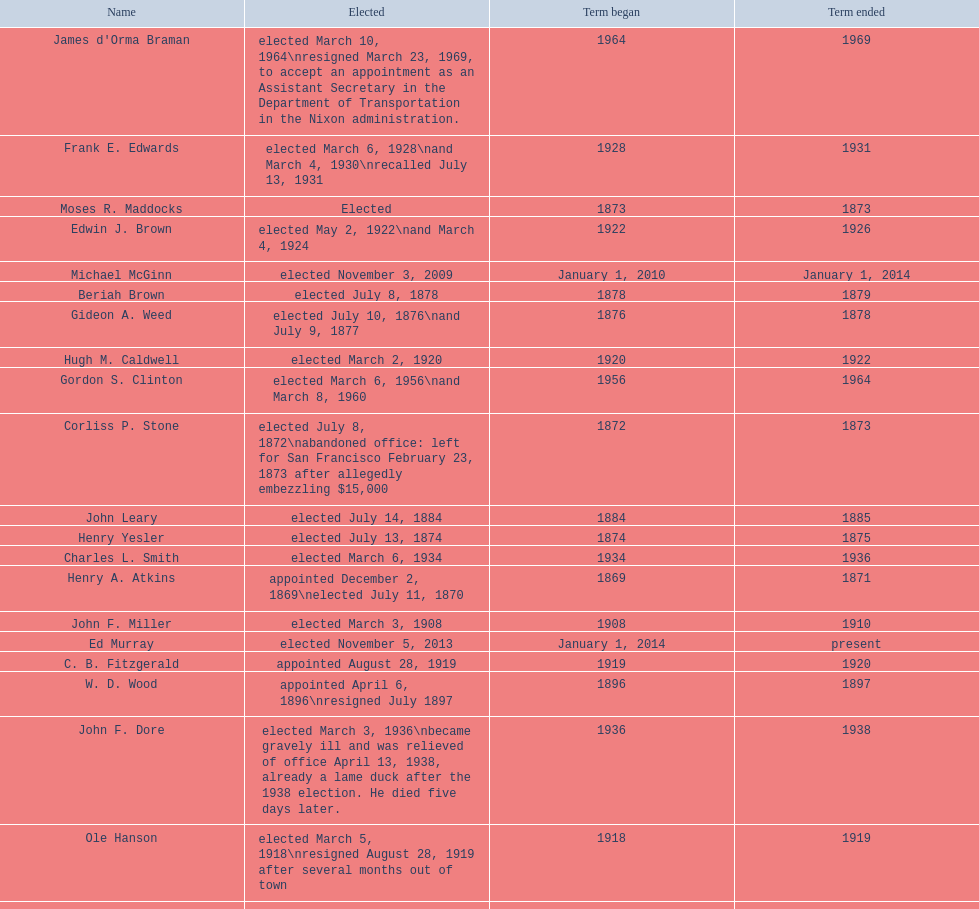Who began their term in 1890? Harry White. Can you give me this table as a dict? {'header': ['Name', 'Elected', 'Term began', 'Term ended'], 'rows': [["James d'Orma Braman", 'elected March 10, 1964\\nresigned March 23, 1969, to accept an appointment as an Assistant Secretary in the Department of Transportation in the Nixon administration.', '1964', '1969'], ['Frank E. Edwards', 'elected March 6, 1928\\nand March 4, 1930\\nrecalled July 13, 1931', '1928', '1931'], ['Moses R. Maddocks', 'Elected', '1873', '1873'], ['Edwin J. Brown', 'elected May 2, 1922\\nand March 4, 1924', '1922', '1926'], ['Michael McGinn', 'elected November 3, 2009', 'January 1, 2010', 'January 1, 2014'], ['Beriah Brown', 'elected July 8, 1878', '1878', '1879'], ['Gideon A. Weed', 'elected July 10, 1876\\nand July 9, 1877', '1876', '1878'], ['Hugh M. Caldwell', 'elected March 2, 1920', '1920', '1922'], ['Gordon S. Clinton', 'elected March 6, 1956\\nand March 8, 1960', '1956', '1964'], ['Corliss P. Stone', 'elected July 8, 1872\\nabandoned office: left for San Francisco February 23, 1873 after allegedly embezzling $15,000', '1872', '1873'], ['John Leary', 'elected July 14, 1884', '1884', '1885'], ['Henry Yesler', 'elected July 13, 1874', '1874', '1875'], ['Charles L. Smith', 'elected March 6, 1934', '1934', '1936'], ['Henry A. Atkins', 'appointed December 2, 1869\\nelected July 11, 1870', '1869', '1871'], ['John F. Miller', 'elected March 3, 1908', '1908', '1910'], ['Ed Murray', 'elected November 5, 2013', 'January 1, 2014', 'present'], ['C. B. Fitzgerald', 'appointed August 28, 1919', '1919', '1920'], ['W. D. Wood', 'appointed April 6, 1896\\nresigned July 1897', '1896', '1897'], ['John F. Dore', 'elected March 3, 1936\\nbecame gravely ill and was relieved of office April 13, 1938, already a lame duck after the 1938 election. He died five days later.', '1936', '1938'], ['Ole Hanson', 'elected March 5, 1918\\nresigned August 28, 1919 after several months out of town', '1918', '1919'], ['John T. Jordan', 'appointed', '1873', '1873'], ['Robert H. Harlin', 'appointed July 14, 1931', '1931', '1932'], ['Leonard Purley Smith', 'elected July 12, 1880\\nand July 11, 1881', '1880', '1882'], ['George W. Dilling', 'appointed February 10, 1911[citation needed]', '1912', ''], ['John F. Dore', 'elected March 8, 1932', '1932', '1934'], ['Byron Phelps', 'elected March 12, 1894', '1894', '1896'], ['Hiram C. Gill', 'elected March 3, 1914', '1914', '1918'], ['John T. Jordan', 'elected July 10, 1871', '1871', '1872'], ['Dr. Thomas T. Minor', 'elected July 11, 1887', '1887', '1888'], ['Henry Yesler', 'elected July 13, 1885', '1885', '1886'], ['Paul Schell', 'elected November 4, 1997', 'January 1, 1998', 'January 1, 2002'], ['Orange Jacobs', 'elected July 14, 1879', '1879', '1880'], ['George W. Hall', 'appointed December 9, 1891', '1891', '1892'], ['Robert Moran', 'elected July 9, 1888\\nand July 8, 1889', '1888', '1890'], ['Floyd C. Miller', 'appointed March 23, 1969', '1969', '1969'], ['William F. Devin', 'elected March 3, 1942, March 7, 1944, March 5, 1946, and March 2, 1948', '1942', '1952'], ['James T. Ronald', 'elected March 8, 1892', '1892', '1894'], ['Gregory J. Nickels', 'elected November 6, 2001\\nand November 8, 2005', 'January 1, 2002', 'January 1, 2010'], ['Norman B. Rice', 'elected November 7, 1989', 'January 1, 1990', 'January 1, 1998'], ['Frank D. Black', 'elected March 9, 1896\\nresigned after three weeks in office', '1896', '1896'], ['John Collins', 'elected July 14, 1873', '1873', '1874'], ['Bailey Gatzert', 'elected August 2, 1875', '1875', '1876'], ['Thomas J. Humes', 'appointed November 19, 1897\\nand elected March 13, 1900', '1897', '1904'], ['Richard A. Ballinger', 'elected March 8, 1904', '1904', '1906'], ['Wesley C. Uhlman', 'elected November 4, 1969\\nand November 6, 1973\\nsurvived recall attempt on July 1, 1975', 'December 1, 1969', 'January 1, 1978'], ['Bertha Knight Landes', 'elected March 9, 1926', '1926', '1928'], ['Henry G. Struve', 'elected July 10, 1882\\nand July 9, 1883', '1882', '1884'], ['John E. Carroll', 'appointed January 27, 1941', '1941', '1941'], ['William Hickman Moore', 'elected March 6, 1906', '1906', '1908'], ['Harry White', 'elected July 14, 1890\\nresigned under pressure November 30, 1891.', '1890', '1891'], ['Allan Pomeroy', 'elected March 4, 1952', '1952', '1956'], ['George F. Cotterill', 'elected March 5, 1912', '1912', '1914'], ['William H. Shoudy', 'elected July 12, 1886', '1886', '1887'], ['Earl Millikin', 'elected March 4, 1941', '1941', '1942'], ['Arthur B. Langlie', "elected March 8, 1938\\nappointed to take office early, April 27, 1938, after Dore's death.\\nelected March 5, 1940\\nresigned January 11, 1941, to become Governor of Washington", '1938', '1941'], ['Charles Royer', 'elected November 8, 1977, November 3, 1981, and November 5, 1985', 'January 1, 1978', 'January 1, 1990'], ['Hiram C. Gill', 'elected March 8, 1910\\nrecalled February 9, 1911', '1910', '1911']]} 